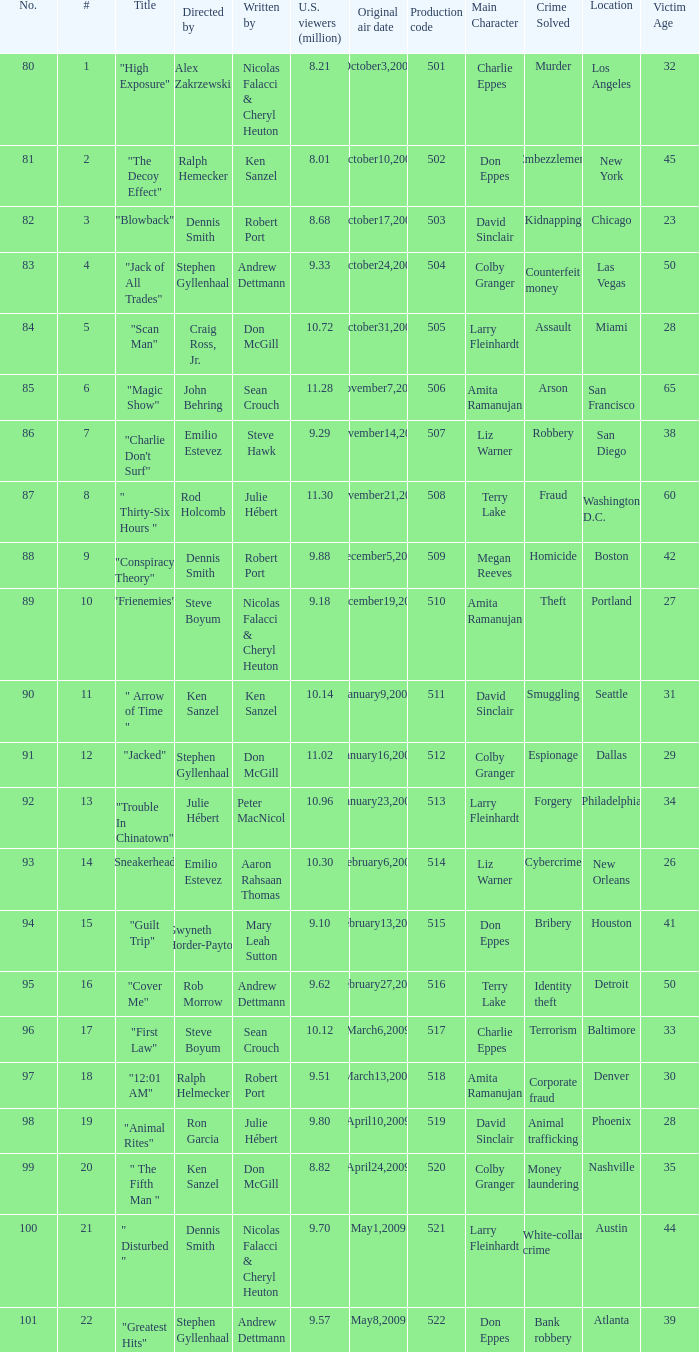How many times did episode 6 originally air? 1.0. 